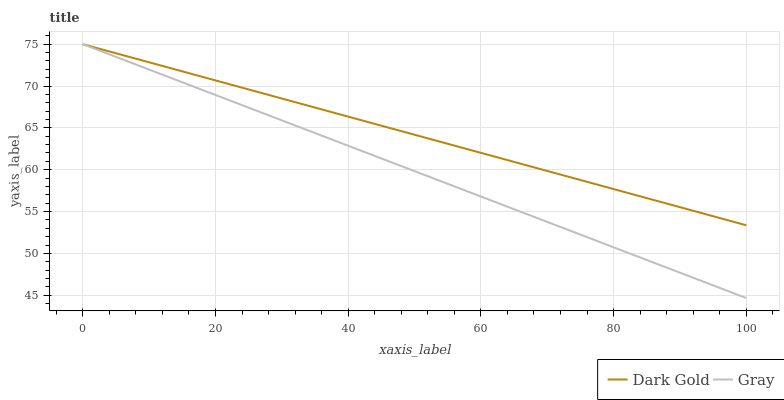Does Gray have the minimum area under the curve?
Answer yes or no. Yes. Does Dark Gold have the maximum area under the curve?
Answer yes or no. Yes. Does Dark Gold have the minimum area under the curve?
Answer yes or no. No. Is Gray the smoothest?
Answer yes or no. Yes. Is Dark Gold the roughest?
Answer yes or no. Yes. Is Dark Gold the smoothest?
Answer yes or no. No. Does Gray have the lowest value?
Answer yes or no. Yes. Does Dark Gold have the lowest value?
Answer yes or no. No. Does Dark Gold have the highest value?
Answer yes or no. Yes. Does Dark Gold intersect Gray?
Answer yes or no. Yes. Is Dark Gold less than Gray?
Answer yes or no. No. Is Dark Gold greater than Gray?
Answer yes or no. No. 